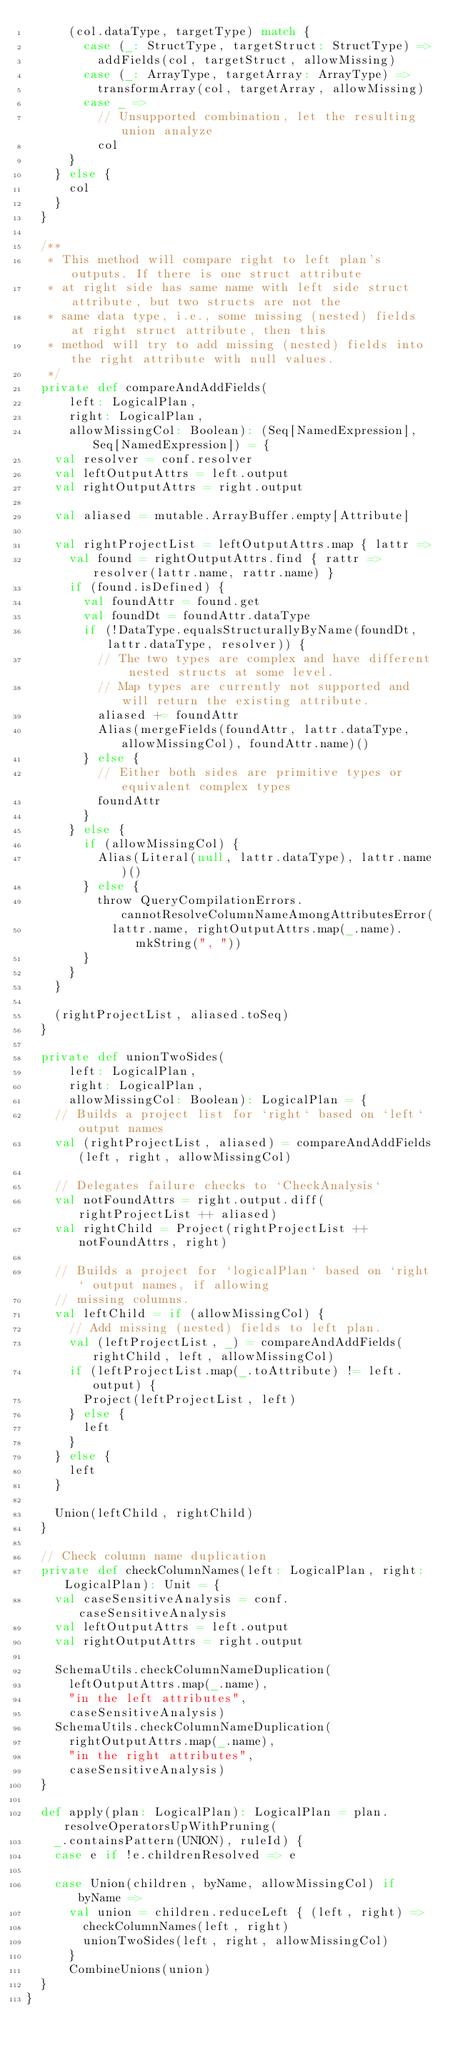<code> <loc_0><loc_0><loc_500><loc_500><_Scala_>      (col.dataType, targetType) match {
        case (_: StructType, targetStruct: StructType) =>
          addFields(col, targetStruct, allowMissing)
        case (_: ArrayType, targetArray: ArrayType) =>
          transformArray(col, targetArray, allowMissing)
        case _ =>
          // Unsupported combination, let the resulting union analyze
          col
      }
    } else {
      col
    }
  }

  /**
   * This method will compare right to left plan's outputs. If there is one struct attribute
   * at right side has same name with left side struct attribute, but two structs are not the
   * same data type, i.e., some missing (nested) fields at right struct attribute, then this
   * method will try to add missing (nested) fields into the right attribute with null values.
   */
  private def compareAndAddFields(
      left: LogicalPlan,
      right: LogicalPlan,
      allowMissingCol: Boolean): (Seq[NamedExpression], Seq[NamedExpression]) = {
    val resolver = conf.resolver
    val leftOutputAttrs = left.output
    val rightOutputAttrs = right.output

    val aliased = mutable.ArrayBuffer.empty[Attribute]

    val rightProjectList = leftOutputAttrs.map { lattr =>
      val found = rightOutputAttrs.find { rattr => resolver(lattr.name, rattr.name) }
      if (found.isDefined) {
        val foundAttr = found.get
        val foundDt = foundAttr.dataType
        if (!DataType.equalsStructurallyByName(foundDt, lattr.dataType, resolver)) {
          // The two types are complex and have different nested structs at some level.
          // Map types are currently not supported and will return the existing attribute.
          aliased += foundAttr
          Alias(mergeFields(foundAttr, lattr.dataType, allowMissingCol), foundAttr.name)()
        } else {
          // Either both sides are primitive types or equivalent complex types
          foundAttr
        }
      } else {
        if (allowMissingCol) {
          Alias(Literal(null, lattr.dataType), lattr.name)()
        } else {
          throw QueryCompilationErrors.cannotResolveColumnNameAmongAttributesError(
            lattr.name, rightOutputAttrs.map(_.name).mkString(", "))
        }
      }
    }

    (rightProjectList, aliased.toSeq)
  }

  private def unionTwoSides(
      left: LogicalPlan,
      right: LogicalPlan,
      allowMissingCol: Boolean): LogicalPlan = {
    // Builds a project list for `right` based on `left` output names
    val (rightProjectList, aliased) = compareAndAddFields(left, right, allowMissingCol)

    // Delegates failure checks to `CheckAnalysis`
    val notFoundAttrs = right.output.diff(rightProjectList ++ aliased)
    val rightChild = Project(rightProjectList ++ notFoundAttrs, right)

    // Builds a project for `logicalPlan` based on `right` output names, if allowing
    // missing columns.
    val leftChild = if (allowMissingCol) {
      // Add missing (nested) fields to left plan.
      val (leftProjectList, _) = compareAndAddFields(rightChild, left, allowMissingCol)
      if (leftProjectList.map(_.toAttribute) != left.output) {
        Project(leftProjectList, left)
      } else {
        left
      }
    } else {
      left
    }

    Union(leftChild, rightChild)
  }

  // Check column name duplication
  private def checkColumnNames(left: LogicalPlan, right: LogicalPlan): Unit = {
    val caseSensitiveAnalysis = conf.caseSensitiveAnalysis
    val leftOutputAttrs = left.output
    val rightOutputAttrs = right.output

    SchemaUtils.checkColumnNameDuplication(
      leftOutputAttrs.map(_.name),
      "in the left attributes",
      caseSensitiveAnalysis)
    SchemaUtils.checkColumnNameDuplication(
      rightOutputAttrs.map(_.name),
      "in the right attributes",
      caseSensitiveAnalysis)
  }

  def apply(plan: LogicalPlan): LogicalPlan = plan.resolveOperatorsUpWithPruning(
    _.containsPattern(UNION), ruleId) {
    case e if !e.childrenResolved => e

    case Union(children, byName, allowMissingCol) if byName =>
      val union = children.reduceLeft { (left, right) =>
        checkColumnNames(left, right)
        unionTwoSides(left, right, allowMissingCol)
      }
      CombineUnions(union)
  }
}
</code> 